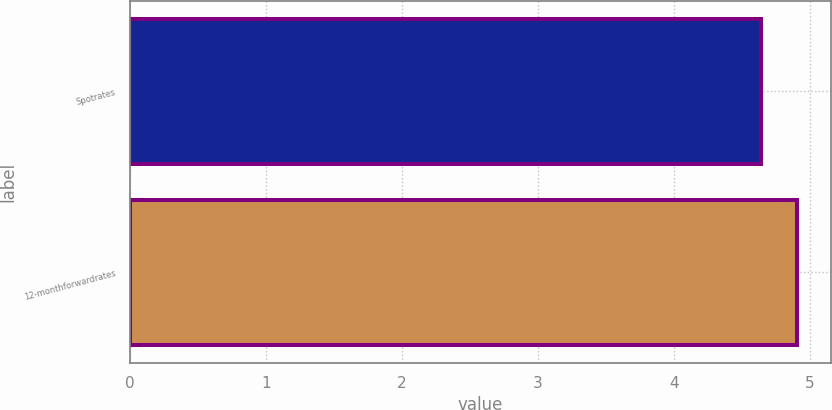<chart> <loc_0><loc_0><loc_500><loc_500><bar_chart><fcel>Spotrates<fcel>12-monthforwardrates<nl><fcel>4.64<fcel>4.91<nl></chart> 